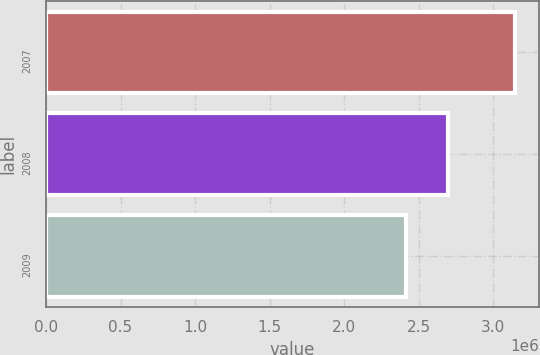Convert chart. <chart><loc_0><loc_0><loc_500><loc_500><bar_chart><fcel>2007<fcel>2008<fcel>2009<nl><fcel>3.14764e+06<fcel>2.6946e+06<fcel>2.41482e+06<nl></chart> 